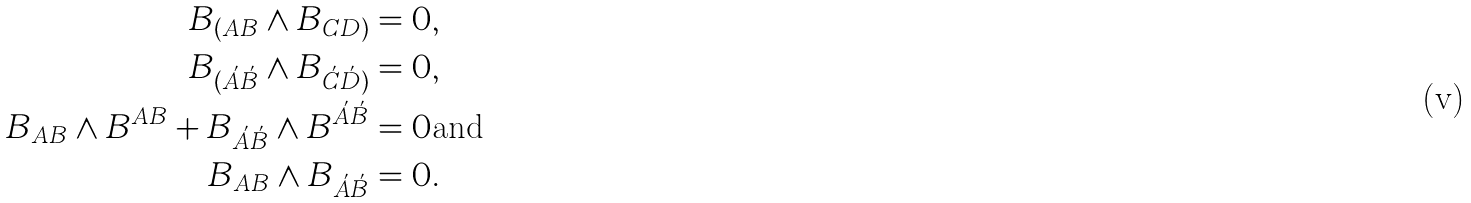<formula> <loc_0><loc_0><loc_500><loc_500>B _ { ( A B } \wedge B _ { C D ) } & = 0 , \\ B _ { ( \acute { A } \acute { B } } \wedge B _ { \acute { C } \acute { D } ) } & = 0 , \\ B _ { A B } \wedge B ^ { A B } + B _ { \acute { A } \acute { B } } \wedge B ^ { \acute { A } \acute { B } } & = 0 \text {and} \\ B _ { A B } \wedge B _ { \acute { A } \acute { B } } & = 0 .</formula> 